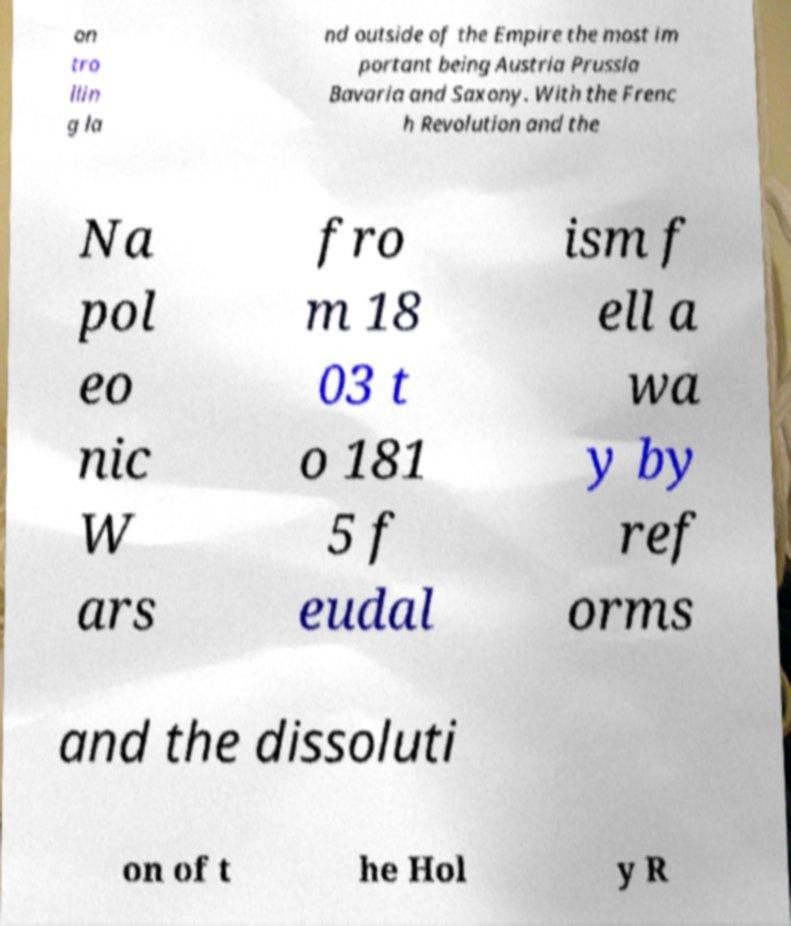Could you assist in decoding the text presented in this image and type it out clearly? on tro llin g la nd outside of the Empire the most im portant being Austria Prussia Bavaria and Saxony. With the Frenc h Revolution and the Na pol eo nic W ars fro m 18 03 t o 181 5 f eudal ism f ell a wa y by ref orms and the dissoluti on of t he Hol y R 